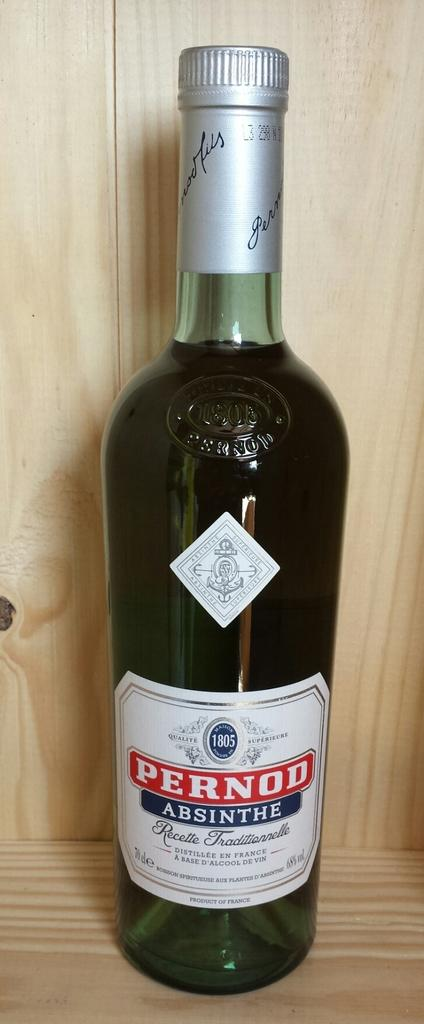What object can be seen in the image? There is a bottle in the image. Can you describe the appearance of the bottle? The bottle is green and white in color. Is there a knot tied in the bottle in the image? No, there is no knot tied in the bottle in the image. What type of statement is written on the bottle in the image? There is no statement written on the bottle in the image; it is simply green and white in color. 